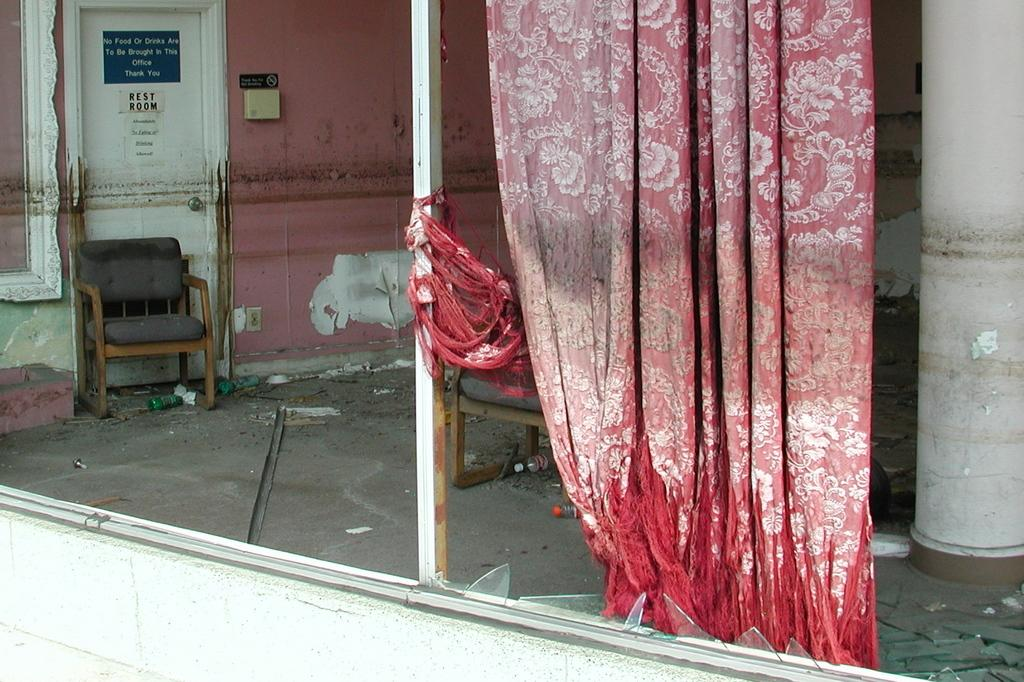What is in the foreground of the image? There is a curtain in the foreground of the image. What is the condition of the window behind the curtain? The window is broken. What type of furniture can be seen in the image? There are chairs in the image. What architectural feature is present in the image? There is a pillar in the image. What type of structure is visible in the image? There is a wall in the image. Is there a way to enter or exit the space in the image? Yes, there is a door in the image. What type of pancake is being served on the table in the image? There is no table or pancake present in the image. Is there a pin holding the curtain in place in the image? There is no pin visible in the image; the curtain is simply hanging over the broken window. 